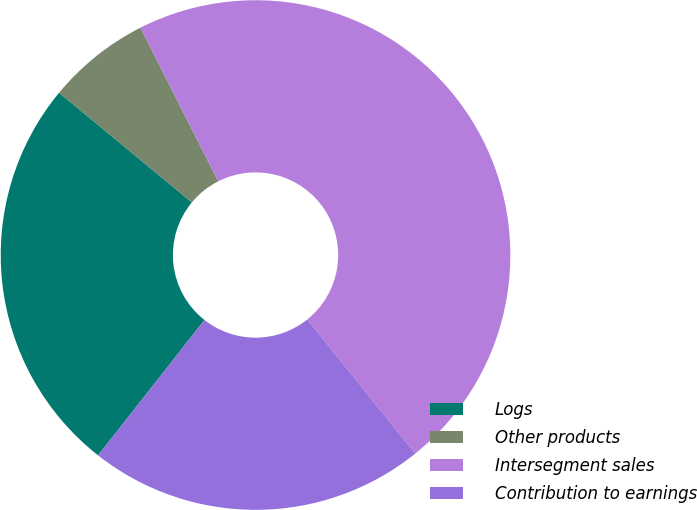<chart> <loc_0><loc_0><loc_500><loc_500><pie_chart><fcel>Logs<fcel>Other products<fcel>Intersegment sales<fcel>Contribution to earnings<nl><fcel>25.39%<fcel>6.55%<fcel>46.68%<fcel>21.38%<nl></chart> 